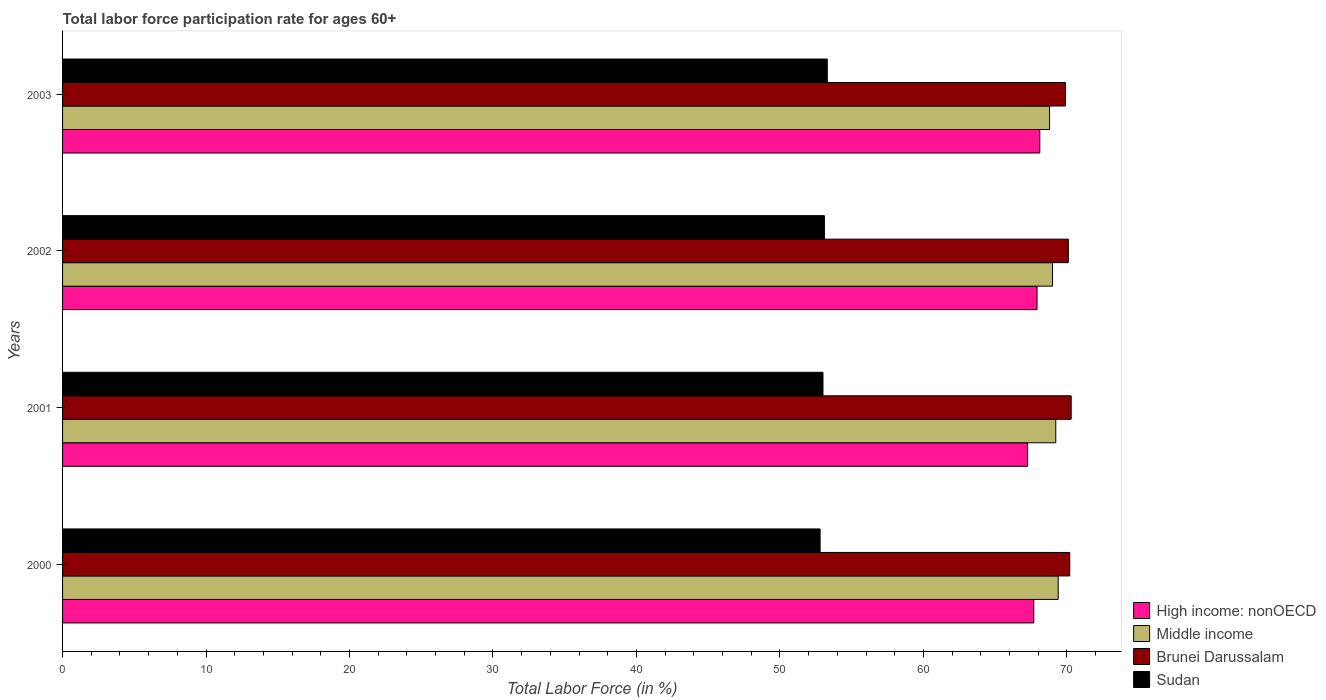Are the number of bars on each tick of the Y-axis equal?
Keep it short and to the point. Yes. How many bars are there on the 3rd tick from the top?
Your answer should be very brief. 4. How many bars are there on the 3rd tick from the bottom?
Provide a succinct answer. 4. What is the label of the 1st group of bars from the top?
Make the answer very short. 2003. In how many cases, is the number of bars for a given year not equal to the number of legend labels?
Your response must be concise. 0. What is the labor force participation rate in Middle income in 2002?
Your answer should be compact. 69. Across all years, what is the maximum labor force participation rate in Brunei Darussalam?
Keep it short and to the point. 70.3. Across all years, what is the minimum labor force participation rate in Brunei Darussalam?
Provide a succinct answer. 69.9. In which year was the labor force participation rate in Sudan minimum?
Your answer should be compact. 2000. What is the total labor force participation rate in Brunei Darussalam in the graph?
Provide a short and direct response. 280.5. What is the difference between the labor force participation rate in Sudan in 2002 and that in 2003?
Offer a very short reply. -0.2. What is the difference between the labor force participation rate in Brunei Darussalam in 2001 and the labor force participation rate in Sudan in 2002?
Give a very brief answer. 17.2. What is the average labor force participation rate in Brunei Darussalam per year?
Make the answer very short. 70.12. In the year 2000, what is the difference between the labor force participation rate in Brunei Darussalam and labor force participation rate in High income: nonOECD?
Provide a short and direct response. 2.51. In how many years, is the labor force participation rate in High income: nonOECD greater than 58 %?
Provide a succinct answer. 4. What is the ratio of the labor force participation rate in Brunei Darussalam in 2000 to that in 2001?
Offer a terse response. 1. Is the labor force participation rate in Brunei Darussalam in 2000 less than that in 2002?
Make the answer very short. No. What is the difference between the highest and the second highest labor force participation rate in Sudan?
Provide a short and direct response. 0.2. In how many years, is the labor force participation rate in Sudan greater than the average labor force participation rate in Sudan taken over all years?
Your answer should be very brief. 2. What does the 2nd bar from the top in 2003 represents?
Provide a short and direct response. Brunei Darussalam. What does the 3rd bar from the bottom in 2003 represents?
Provide a short and direct response. Brunei Darussalam. Is it the case that in every year, the sum of the labor force participation rate in Sudan and labor force participation rate in Brunei Darussalam is greater than the labor force participation rate in Middle income?
Your response must be concise. Yes. How many bars are there?
Provide a succinct answer. 16. Are all the bars in the graph horizontal?
Provide a succinct answer. Yes. Are the values on the major ticks of X-axis written in scientific E-notation?
Your answer should be compact. No. Does the graph contain any zero values?
Keep it short and to the point. No. Does the graph contain grids?
Make the answer very short. No. Where does the legend appear in the graph?
Keep it short and to the point. Bottom right. How many legend labels are there?
Offer a very short reply. 4. What is the title of the graph?
Ensure brevity in your answer.  Total labor force participation rate for ages 60+. What is the label or title of the X-axis?
Your answer should be very brief. Total Labor Force (in %). What is the label or title of the Y-axis?
Make the answer very short. Years. What is the Total Labor Force (in %) of High income: nonOECD in 2000?
Your answer should be very brief. 67.69. What is the Total Labor Force (in %) in Middle income in 2000?
Provide a succinct answer. 69.39. What is the Total Labor Force (in %) of Brunei Darussalam in 2000?
Make the answer very short. 70.2. What is the Total Labor Force (in %) in Sudan in 2000?
Provide a short and direct response. 52.8. What is the Total Labor Force (in %) in High income: nonOECD in 2001?
Offer a terse response. 67.26. What is the Total Labor Force (in %) in Middle income in 2001?
Give a very brief answer. 69.23. What is the Total Labor Force (in %) of Brunei Darussalam in 2001?
Provide a succinct answer. 70.3. What is the Total Labor Force (in %) of High income: nonOECD in 2002?
Offer a very short reply. 67.92. What is the Total Labor Force (in %) of Middle income in 2002?
Offer a very short reply. 69. What is the Total Labor Force (in %) in Brunei Darussalam in 2002?
Provide a succinct answer. 70.1. What is the Total Labor Force (in %) in Sudan in 2002?
Ensure brevity in your answer.  53.1. What is the Total Labor Force (in %) in High income: nonOECD in 2003?
Offer a terse response. 68.11. What is the Total Labor Force (in %) of Middle income in 2003?
Give a very brief answer. 68.79. What is the Total Labor Force (in %) of Brunei Darussalam in 2003?
Offer a very short reply. 69.9. What is the Total Labor Force (in %) of Sudan in 2003?
Your response must be concise. 53.3. Across all years, what is the maximum Total Labor Force (in %) of High income: nonOECD?
Provide a short and direct response. 68.11. Across all years, what is the maximum Total Labor Force (in %) in Middle income?
Your answer should be compact. 69.39. Across all years, what is the maximum Total Labor Force (in %) in Brunei Darussalam?
Your answer should be compact. 70.3. Across all years, what is the maximum Total Labor Force (in %) of Sudan?
Your answer should be compact. 53.3. Across all years, what is the minimum Total Labor Force (in %) in High income: nonOECD?
Give a very brief answer. 67.26. Across all years, what is the minimum Total Labor Force (in %) in Middle income?
Your answer should be very brief. 68.79. Across all years, what is the minimum Total Labor Force (in %) in Brunei Darussalam?
Offer a terse response. 69.9. Across all years, what is the minimum Total Labor Force (in %) in Sudan?
Provide a succinct answer. 52.8. What is the total Total Labor Force (in %) in High income: nonOECD in the graph?
Provide a short and direct response. 270.99. What is the total Total Labor Force (in %) in Middle income in the graph?
Provide a succinct answer. 276.41. What is the total Total Labor Force (in %) of Brunei Darussalam in the graph?
Provide a short and direct response. 280.5. What is the total Total Labor Force (in %) of Sudan in the graph?
Ensure brevity in your answer.  212.2. What is the difference between the Total Labor Force (in %) in High income: nonOECD in 2000 and that in 2001?
Keep it short and to the point. 0.43. What is the difference between the Total Labor Force (in %) of Middle income in 2000 and that in 2001?
Ensure brevity in your answer.  0.17. What is the difference between the Total Labor Force (in %) of Brunei Darussalam in 2000 and that in 2001?
Make the answer very short. -0.1. What is the difference between the Total Labor Force (in %) in Sudan in 2000 and that in 2001?
Provide a short and direct response. -0.2. What is the difference between the Total Labor Force (in %) of High income: nonOECD in 2000 and that in 2002?
Ensure brevity in your answer.  -0.23. What is the difference between the Total Labor Force (in %) in Middle income in 2000 and that in 2002?
Your answer should be compact. 0.4. What is the difference between the Total Labor Force (in %) of Brunei Darussalam in 2000 and that in 2002?
Make the answer very short. 0.1. What is the difference between the Total Labor Force (in %) in High income: nonOECD in 2000 and that in 2003?
Provide a short and direct response. -0.42. What is the difference between the Total Labor Force (in %) in Middle income in 2000 and that in 2003?
Offer a very short reply. 0.6. What is the difference between the Total Labor Force (in %) of Brunei Darussalam in 2000 and that in 2003?
Provide a succinct answer. 0.3. What is the difference between the Total Labor Force (in %) of Sudan in 2000 and that in 2003?
Offer a terse response. -0.5. What is the difference between the Total Labor Force (in %) of High income: nonOECD in 2001 and that in 2002?
Your answer should be very brief. -0.66. What is the difference between the Total Labor Force (in %) in Middle income in 2001 and that in 2002?
Keep it short and to the point. 0.23. What is the difference between the Total Labor Force (in %) in Brunei Darussalam in 2001 and that in 2002?
Keep it short and to the point. 0.2. What is the difference between the Total Labor Force (in %) in High income: nonOECD in 2001 and that in 2003?
Provide a short and direct response. -0.85. What is the difference between the Total Labor Force (in %) in Middle income in 2001 and that in 2003?
Provide a succinct answer. 0.43. What is the difference between the Total Labor Force (in %) in Sudan in 2001 and that in 2003?
Give a very brief answer. -0.3. What is the difference between the Total Labor Force (in %) in High income: nonOECD in 2002 and that in 2003?
Offer a terse response. -0.19. What is the difference between the Total Labor Force (in %) in Middle income in 2002 and that in 2003?
Provide a succinct answer. 0.21. What is the difference between the Total Labor Force (in %) of Brunei Darussalam in 2002 and that in 2003?
Keep it short and to the point. 0.2. What is the difference between the Total Labor Force (in %) in High income: nonOECD in 2000 and the Total Labor Force (in %) in Middle income in 2001?
Offer a terse response. -1.53. What is the difference between the Total Labor Force (in %) in High income: nonOECD in 2000 and the Total Labor Force (in %) in Brunei Darussalam in 2001?
Offer a terse response. -2.61. What is the difference between the Total Labor Force (in %) in High income: nonOECD in 2000 and the Total Labor Force (in %) in Sudan in 2001?
Your answer should be compact. 14.69. What is the difference between the Total Labor Force (in %) of Middle income in 2000 and the Total Labor Force (in %) of Brunei Darussalam in 2001?
Provide a succinct answer. -0.91. What is the difference between the Total Labor Force (in %) in Middle income in 2000 and the Total Labor Force (in %) in Sudan in 2001?
Offer a terse response. 16.39. What is the difference between the Total Labor Force (in %) of Brunei Darussalam in 2000 and the Total Labor Force (in %) of Sudan in 2001?
Your answer should be very brief. 17.2. What is the difference between the Total Labor Force (in %) in High income: nonOECD in 2000 and the Total Labor Force (in %) in Middle income in 2002?
Offer a very short reply. -1.31. What is the difference between the Total Labor Force (in %) of High income: nonOECD in 2000 and the Total Labor Force (in %) of Brunei Darussalam in 2002?
Your response must be concise. -2.41. What is the difference between the Total Labor Force (in %) of High income: nonOECD in 2000 and the Total Labor Force (in %) of Sudan in 2002?
Your response must be concise. 14.59. What is the difference between the Total Labor Force (in %) in Middle income in 2000 and the Total Labor Force (in %) in Brunei Darussalam in 2002?
Make the answer very short. -0.71. What is the difference between the Total Labor Force (in %) in Middle income in 2000 and the Total Labor Force (in %) in Sudan in 2002?
Offer a terse response. 16.29. What is the difference between the Total Labor Force (in %) in High income: nonOECD in 2000 and the Total Labor Force (in %) in Middle income in 2003?
Offer a terse response. -1.1. What is the difference between the Total Labor Force (in %) of High income: nonOECD in 2000 and the Total Labor Force (in %) of Brunei Darussalam in 2003?
Keep it short and to the point. -2.21. What is the difference between the Total Labor Force (in %) of High income: nonOECD in 2000 and the Total Labor Force (in %) of Sudan in 2003?
Give a very brief answer. 14.39. What is the difference between the Total Labor Force (in %) of Middle income in 2000 and the Total Labor Force (in %) of Brunei Darussalam in 2003?
Keep it short and to the point. -0.51. What is the difference between the Total Labor Force (in %) of Middle income in 2000 and the Total Labor Force (in %) of Sudan in 2003?
Provide a succinct answer. 16.09. What is the difference between the Total Labor Force (in %) of High income: nonOECD in 2001 and the Total Labor Force (in %) of Middle income in 2002?
Offer a terse response. -1.74. What is the difference between the Total Labor Force (in %) of High income: nonOECD in 2001 and the Total Labor Force (in %) of Brunei Darussalam in 2002?
Your response must be concise. -2.84. What is the difference between the Total Labor Force (in %) in High income: nonOECD in 2001 and the Total Labor Force (in %) in Sudan in 2002?
Give a very brief answer. 14.16. What is the difference between the Total Labor Force (in %) in Middle income in 2001 and the Total Labor Force (in %) in Brunei Darussalam in 2002?
Make the answer very short. -0.87. What is the difference between the Total Labor Force (in %) of Middle income in 2001 and the Total Labor Force (in %) of Sudan in 2002?
Give a very brief answer. 16.13. What is the difference between the Total Labor Force (in %) of High income: nonOECD in 2001 and the Total Labor Force (in %) of Middle income in 2003?
Provide a succinct answer. -1.53. What is the difference between the Total Labor Force (in %) of High income: nonOECD in 2001 and the Total Labor Force (in %) of Brunei Darussalam in 2003?
Provide a short and direct response. -2.64. What is the difference between the Total Labor Force (in %) in High income: nonOECD in 2001 and the Total Labor Force (in %) in Sudan in 2003?
Make the answer very short. 13.96. What is the difference between the Total Labor Force (in %) in Middle income in 2001 and the Total Labor Force (in %) in Brunei Darussalam in 2003?
Your answer should be very brief. -0.67. What is the difference between the Total Labor Force (in %) of Middle income in 2001 and the Total Labor Force (in %) of Sudan in 2003?
Offer a very short reply. 15.93. What is the difference between the Total Labor Force (in %) in Brunei Darussalam in 2001 and the Total Labor Force (in %) in Sudan in 2003?
Your answer should be compact. 17. What is the difference between the Total Labor Force (in %) of High income: nonOECD in 2002 and the Total Labor Force (in %) of Middle income in 2003?
Provide a succinct answer. -0.87. What is the difference between the Total Labor Force (in %) of High income: nonOECD in 2002 and the Total Labor Force (in %) of Brunei Darussalam in 2003?
Your response must be concise. -1.98. What is the difference between the Total Labor Force (in %) in High income: nonOECD in 2002 and the Total Labor Force (in %) in Sudan in 2003?
Your answer should be compact. 14.62. What is the difference between the Total Labor Force (in %) of Middle income in 2002 and the Total Labor Force (in %) of Brunei Darussalam in 2003?
Offer a very short reply. -0.9. What is the difference between the Total Labor Force (in %) in Middle income in 2002 and the Total Labor Force (in %) in Sudan in 2003?
Give a very brief answer. 15.7. What is the difference between the Total Labor Force (in %) in Brunei Darussalam in 2002 and the Total Labor Force (in %) in Sudan in 2003?
Give a very brief answer. 16.8. What is the average Total Labor Force (in %) in High income: nonOECD per year?
Your response must be concise. 67.75. What is the average Total Labor Force (in %) in Middle income per year?
Your response must be concise. 69.1. What is the average Total Labor Force (in %) of Brunei Darussalam per year?
Keep it short and to the point. 70.12. What is the average Total Labor Force (in %) of Sudan per year?
Keep it short and to the point. 53.05. In the year 2000, what is the difference between the Total Labor Force (in %) in High income: nonOECD and Total Labor Force (in %) in Middle income?
Keep it short and to the point. -1.7. In the year 2000, what is the difference between the Total Labor Force (in %) of High income: nonOECD and Total Labor Force (in %) of Brunei Darussalam?
Ensure brevity in your answer.  -2.51. In the year 2000, what is the difference between the Total Labor Force (in %) of High income: nonOECD and Total Labor Force (in %) of Sudan?
Make the answer very short. 14.89. In the year 2000, what is the difference between the Total Labor Force (in %) of Middle income and Total Labor Force (in %) of Brunei Darussalam?
Keep it short and to the point. -0.81. In the year 2000, what is the difference between the Total Labor Force (in %) in Middle income and Total Labor Force (in %) in Sudan?
Your response must be concise. 16.59. In the year 2000, what is the difference between the Total Labor Force (in %) of Brunei Darussalam and Total Labor Force (in %) of Sudan?
Make the answer very short. 17.4. In the year 2001, what is the difference between the Total Labor Force (in %) of High income: nonOECD and Total Labor Force (in %) of Middle income?
Provide a succinct answer. -1.96. In the year 2001, what is the difference between the Total Labor Force (in %) of High income: nonOECD and Total Labor Force (in %) of Brunei Darussalam?
Your answer should be compact. -3.04. In the year 2001, what is the difference between the Total Labor Force (in %) in High income: nonOECD and Total Labor Force (in %) in Sudan?
Offer a very short reply. 14.26. In the year 2001, what is the difference between the Total Labor Force (in %) of Middle income and Total Labor Force (in %) of Brunei Darussalam?
Offer a terse response. -1.07. In the year 2001, what is the difference between the Total Labor Force (in %) of Middle income and Total Labor Force (in %) of Sudan?
Provide a succinct answer. 16.23. In the year 2001, what is the difference between the Total Labor Force (in %) in Brunei Darussalam and Total Labor Force (in %) in Sudan?
Offer a terse response. 17.3. In the year 2002, what is the difference between the Total Labor Force (in %) of High income: nonOECD and Total Labor Force (in %) of Middle income?
Provide a short and direct response. -1.08. In the year 2002, what is the difference between the Total Labor Force (in %) in High income: nonOECD and Total Labor Force (in %) in Brunei Darussalam?
Offer a very short reply. -2.18. In the year 2002, what is the difference between the Total Labor Force (in %) in High income: nonOECD and Total Labor Force (in %) in Sudan?
Your answer should be very brief. 14.82. In the year 2002, what is the difference between the Total Labor Force (in %) of Middle income and Total Labor Force (in %) of Brunei Darussalam?
Offer a very short reply. -1.1. In the year 2002, what is the difference between the Total Labor Force (in %) in Middle income and Total Labor Force (in %) in Sudan?
Your answer should be compact. 15.9. In the year 2003, what is the difference between the Total Labor Force (in %) of High income: nonOECD and Total Labor Force (in %) of Middle income?
Your answer should be very brief. -0.68. In the year 2003, what is the difference between the Total Labor Force (in %) of High income: nonOECD and Total Labor Force (in %) of Brunei Darussalam?
Your answer should be very brief. -1.79. In the year 2003, what is the difference between the Total Labor Force (in %) of High income: nonOECD and Total Labor Force (in %) of Sudan?
Your answer should be very brief. 14.81. In the year 2003, what is the difference between the Total Labor Force (in %) in Middle income and Total Labor Force (in %) in Brunei Darussalam?
Offer a very short reply. -1.11. In the year 2003, what is the difference between the Total Labor Force (in %) in Middle income and Total Labor Force (in %) in Sudan?
Offer a terse response. 15.49. What is the ratio of the Total Labor Force (in %) in High income: nonOECD in 2000 to that in 2001?
Provide a succinct answer. 1.01. What is the ratio of the Total Labor Force (in %) in Brunei Darussalam in 2000 to that in 2001?
Your answer should be very brief. 1. What is the ratio of the Total Labor Force (in %) in Sudan in 2000 to that in 2001?
Provide a succinct answer. 1. What is the ratio of the Total Labor Force (in %) in High income: nonOECD in 2000 to that in 2002?
Your answer should be very brief. 1. What is the ratio of the Total Labor Force (in %) of Middle income in 2000 to that in 2002?
Offer a terse response. 1.01. What is the ratio of the Total Labor Force (in %) of Sudan in 2000 to that in 2002?
Make the answer very short. 0.99. What is the ratio of the Total Labor Force (in %) in Middle income in 2000 to that in 2003?
Your response must be concise. 1.01. What is the ratio of the Total Labor Force (in %) in Brunei Darussalam in 2000 to that in 2003?
Keep it short and to the point. 1. What is the ratio of the Total Labor Force (in %) in Sudan in 2000 to that in 2003?
Ensure brevity in your answer.  0.99. What is the ratio of the Total Labor Force (in %) of High income: nonOECD in 2001 to that in 2002?
Make the answer very short. 0.99. What is the ratio of the Total Labor Force (in %) of Sudan in 2001 to that in 2002?
Offer a terse response. 1. What is the ratio of the Total Labor Force (in %) of High income: nonOECD in 2001 to that in 2003?
Provide a succinct answer. 0.99. What is the ratio of the Total Labor Force (in %) of Middle income in 2001 to that in 2003?
Offer a terse response. 1.01. What is the ratio of the Total Labor Force (in %) in High income: nonOECD in 2002 to that in 2003?
Keep it short and to the point. 1. What is the ratio of the Total Labor Force (in %) in Middle income in 2002 to that in 2003?
Offer a very short reply. 1. What is the ratio of the Total Labor Force (in %) of Brunei Darussalam in 2002 to that in 2003?
Ensure brevity in your answer.  1. What is the ratio of the Total Labor Force (in %) in Sudan in 2002 to that in 2003?
Offer a very short reply. 1. What is the difference between the highest and the second highest Total Labor Force (in %) of High income: nonOECD?
Your response must be concise. 0.19. What is the difference between the highest and the second highest Total Labor Force (in %) of Middle income?
Your answer should be very brief. 0.17. What is the difference between the highest and the second highest Total Labor Force (in %) of Sudan?
Provide a succinct answer. 0.2. What is the difference between the highest and the lowest Total Labor Force (in %) of High income: nonOECD?
Keep it short and to the point. 0.85. What is the difference between the highest and the lowest Total Labor Force (in %) of Middle income?
Make the answer very short. 0.6. What is the difference between the highest and the lowest Total Labor Force (in %) of Brunei Darussalam?
Your response must be concise. 0.4. What is the difference between the highest and the lowest Total Labor Force (in %) of Sudan?
Make the answer very short. 0.5. 